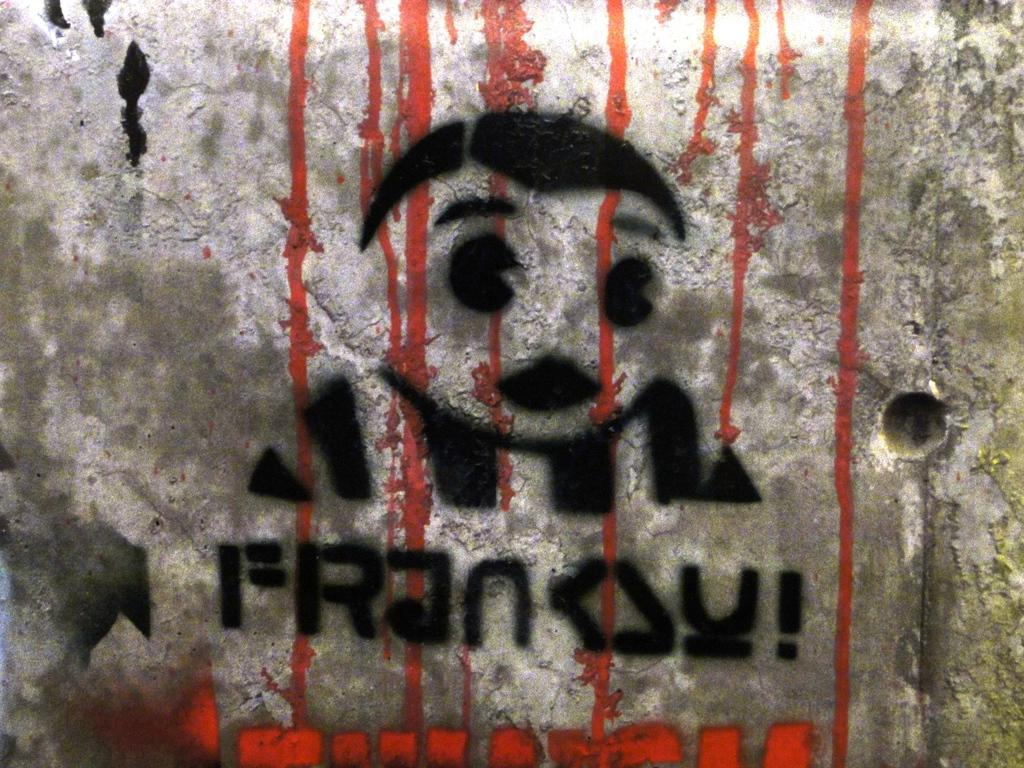What is present on the wall in the image? There is a painting on the wall in the image. What is the primary function of the wall in the image? The wall serves as a support for the painting. What type of soda is being served in the image? There is no soda present in the image; it only features a wall with a painting on it. What color is the army uniform in the image? There is no army or uniform present in the image; it only features a wall with a painting on it. 